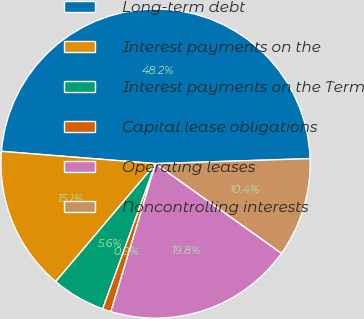Convert chart to OTSL. <chart><loc_0><loc_0><loc_500><loc_500><pie_chart><fcel>Long-term debt<fcel>Interest payments on the<fcel>Interest payments on the Term<fcel>Capital lease obligations<fcel>Operating leases<fcel>Noncontrolling interests<nl><fcel>48.22%<fcel>15.09%<fcel>5.62%<fcel>0.89%<fcel>19.82%<fcel>10.36%<nl></chart> 